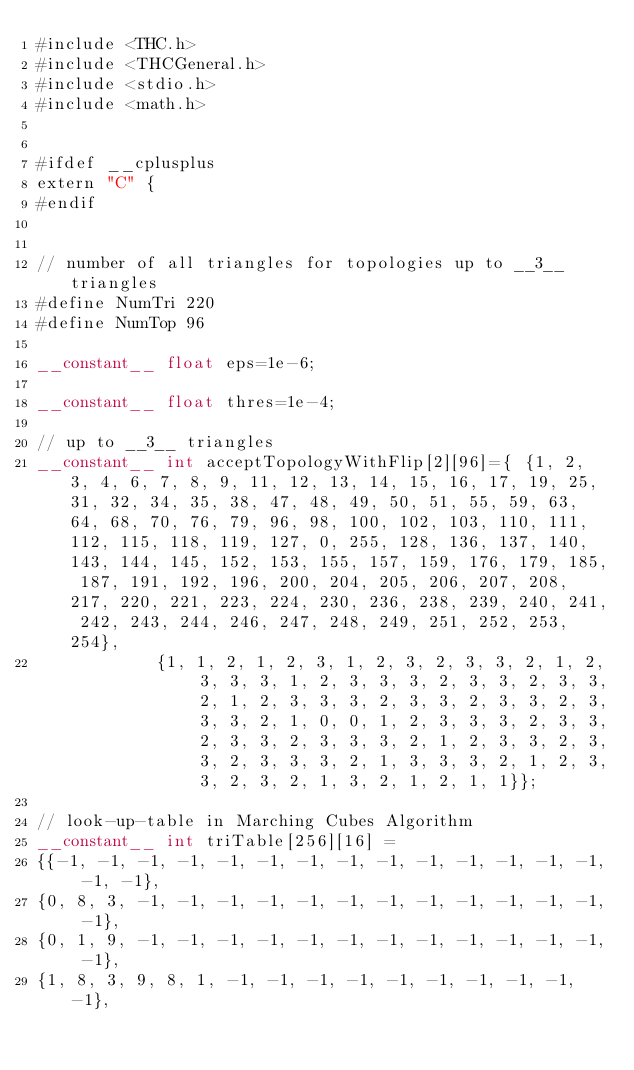<code> <loc_0><loc_0><loc_500><loc_500><_Cuda_>#include <THC.h>
#include <THCGeneral.h>
#include <stdio.h>
#include <math.h>


#ifdef __cplusplus
extern "C" {
#endif


// number of all triangles for topologies up to __3__ triangles
#define NumTri 220 
#define NumTop 96 

__constant__ float eps=1e-6;

__constant__ float thres=1e-4;

// up to __3__ triangles
__constant__ int acceptTopologyWithFlip[2][96]={ {1, 2, 3, 4, 6, 7, 8, 9, 11, 12, 13, 14, 15, 16, 17, 19, 25, 31, 32, 34, 35, 38, 47, 48, 49, 50, 51, 55, 59, 63, 64, 68, 70, 76, 79, 96, 98, 100, 102, 103, 110, 111, 112, 115, 118, 119, 127, 0, 255, 128, 136, 137, 140, 143, 144, 145, 152, 153, 155, 157, 159, 176, 179, 185, 187, 191, 192, 196, 200, 204, 205, 206, 207, 208, 217, 220, 221, 223, 224, 230, 236, 238, 239, 240, 241, 242, 243, 244, 246, 247, 248, 249, 251, 252, 253, 254},
				    {1, 1, 2, 1, 2, 3, 1, 2, 3, 2, 3, 3, 2, 1, 2, 3, 3, 3, 1, 2, 3, 3, 3, 2, 3, 3, 2, 3, 3, 2, 1, 2, 3, 3, 3, 2, 3, 3, 2, 3, 3, 2, 3, 3, 3, 2, 1, 0, 0, 1, 2, 3, 3, 3, 2, 3, 3, 2, 3, 3, 2, 3, 3, 3, 2, 1, 2, 3, 3, 2, 3, 3, 2, 3, 3, 3, 2, 1, 3, 3, 3, 2, 1, 2, 3, 3, 2, 3, 2, 1, 3, 2, 1, 2, 1, 1}};

// look-up-table in Marching Cubes Algorithm
__constant__ int triTable[256][16] =
{{-1, -1, -1, -1, -1, -1, -1, -1, -1, -1, -1, -1, -1, -1, -1, -1},
{0, 8, 3, -1, -1, -1, -1, -1, -1, -1, -1, -1, -1, -1, -1, -1},
{0, 1, 9, -1, -1, -1, -1, -1, -1, -1, -1, -1, -1, -1, -1, -1},
{1, 8, 3, 9, 8, 1, -1, -1, -1, -1, -1, -1, -1, -1, -1, -1},</code> 